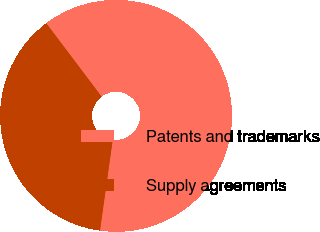Convert chart. <chart><loc_0><loc_0><loc_500><loc_500><pie_chart><fcel>Patents and trademarks<fcel>Supply agreements<nl><fcel>62.5%<fcel>37.5%<nl></chart> 